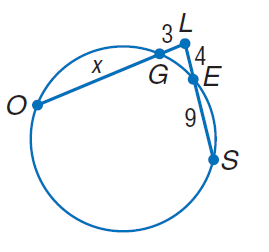Question: Find x. Round to the nearest tenth, if necessary.
Choices:
A. 3
B. 4
C. 9
D. 14.3
Answer with the letter. Answer: D 